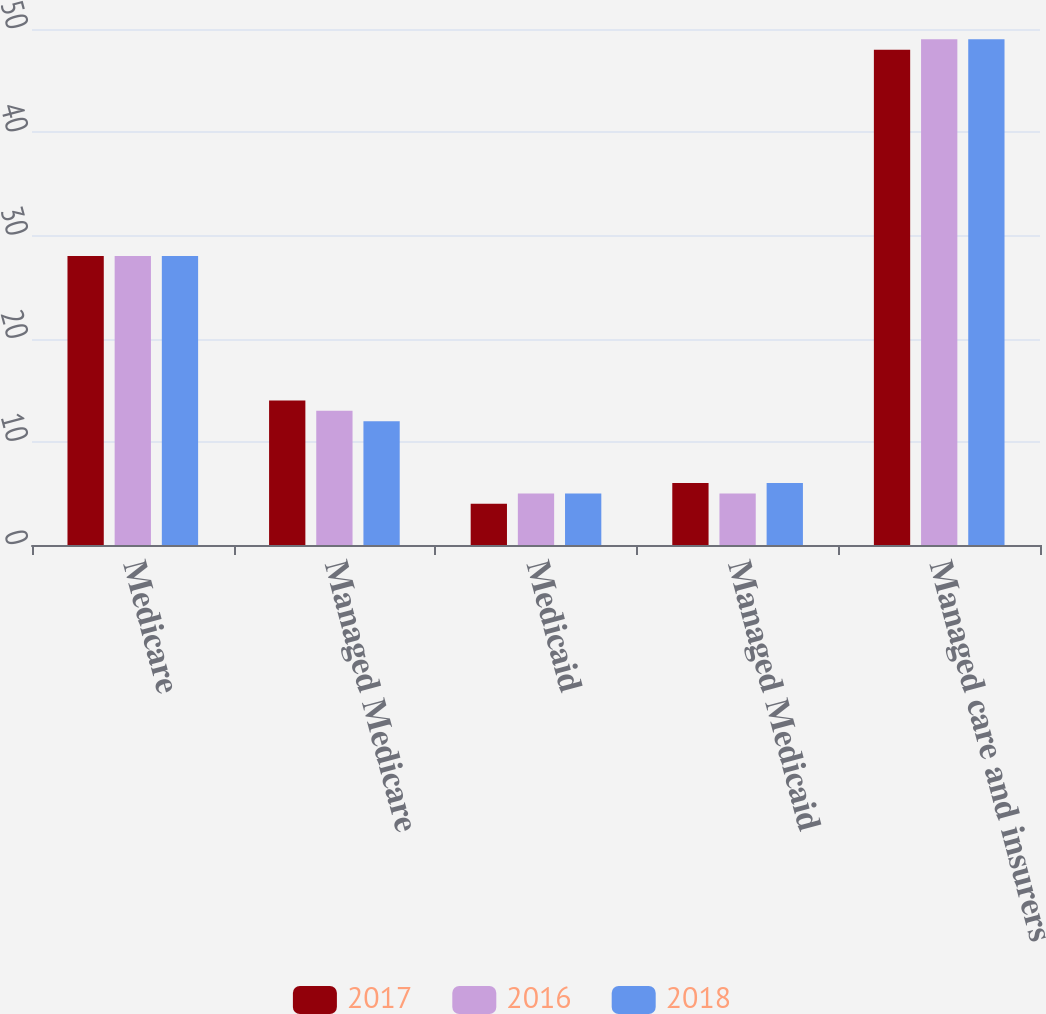Convert chart. <chart><loc_0><loc_0><loc_500><loc_500><stacked_bar_chart><ecel><fcel>Medicare<fcel>Managed Medicare<fcel>Medicaid<fcel>Managed Medicaid<fcel>Managed care and insurers<nl><fcel>2017<fcel>28<fcel>14<fcel>4<fcel>6<fcel>48<nl><fcel>2016<fcel>28<fcel>13<fcel>5<fcel>5<fcel>49<nl><fcel>2018<fcel>28<fcel>12<fcel>5<fcel>6<fcel>49<nl></chart> 